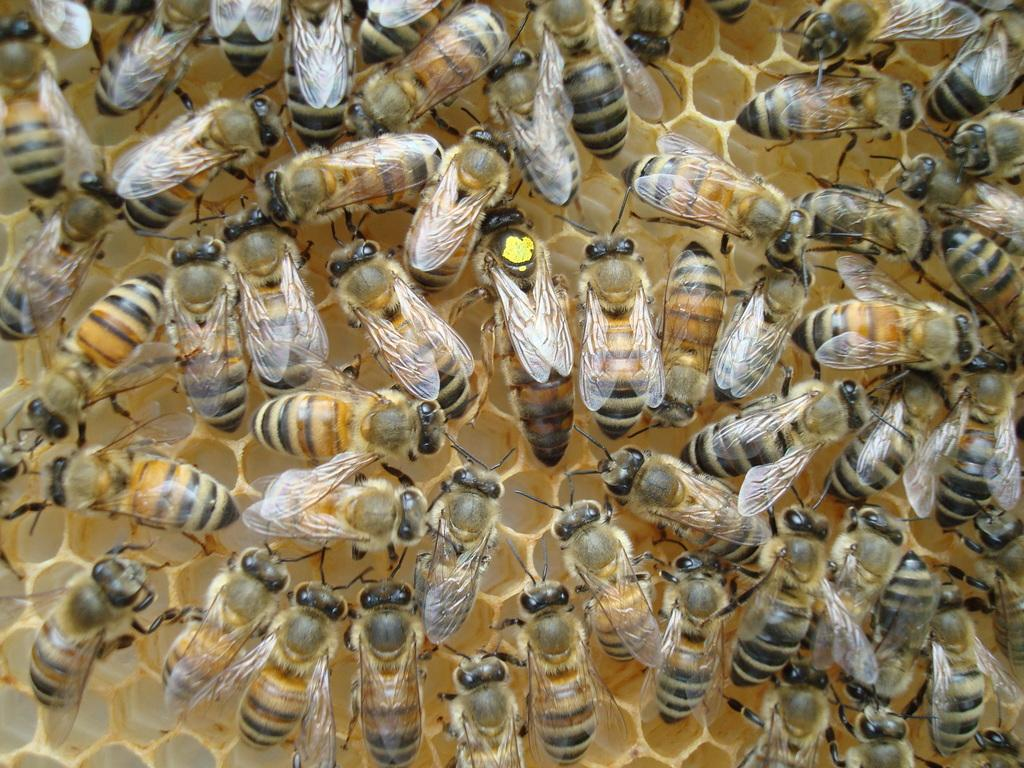What type of living organisms can be seen in the image? Insects can be seen in the image. What type of record can be seen spinning on the plate in the image? There is no record or plate present in the image; it features insects. How many pizzas are visible in the image? There are no pizzas present in the image; it features insects. 